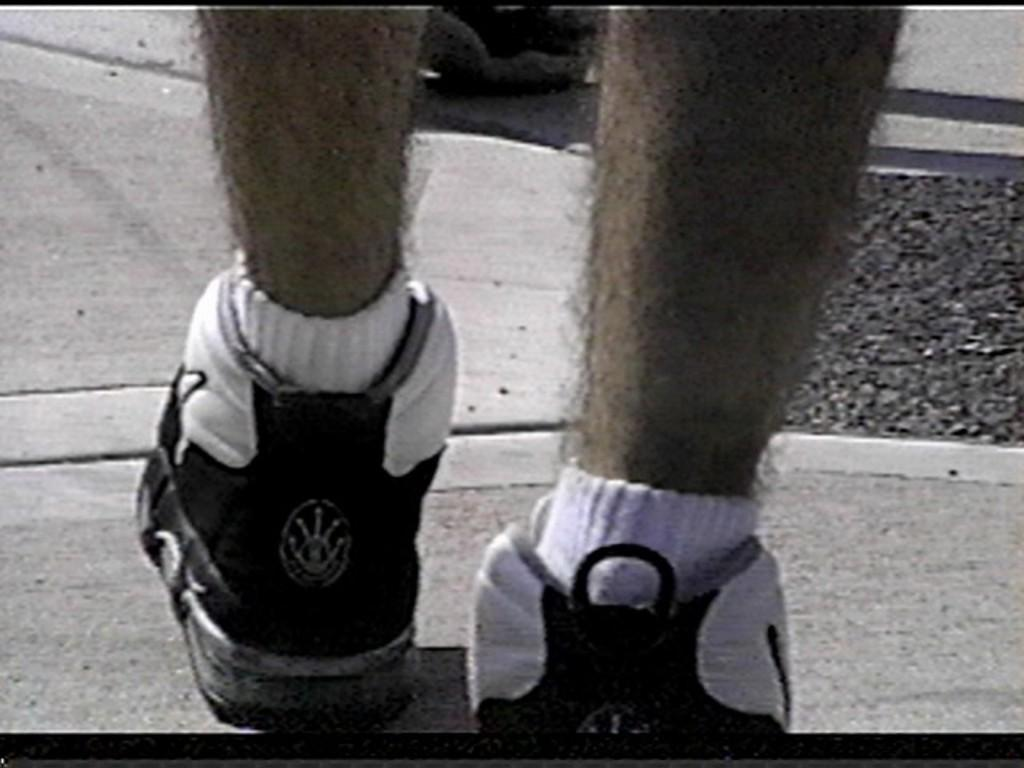What body parts are visible in the image? There are two legs visible in the image. What are the legs wearing? The legs are wearing shoes. Where is the throne located in the image? There is no throne present in the image. What type of food can be seen on the table in the image? There is no table or food present in the image. 